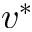Convert formula to latex. <formula><loc_0><loc_0><loc_500><loc_500>v ^ { \ast }</formula> 